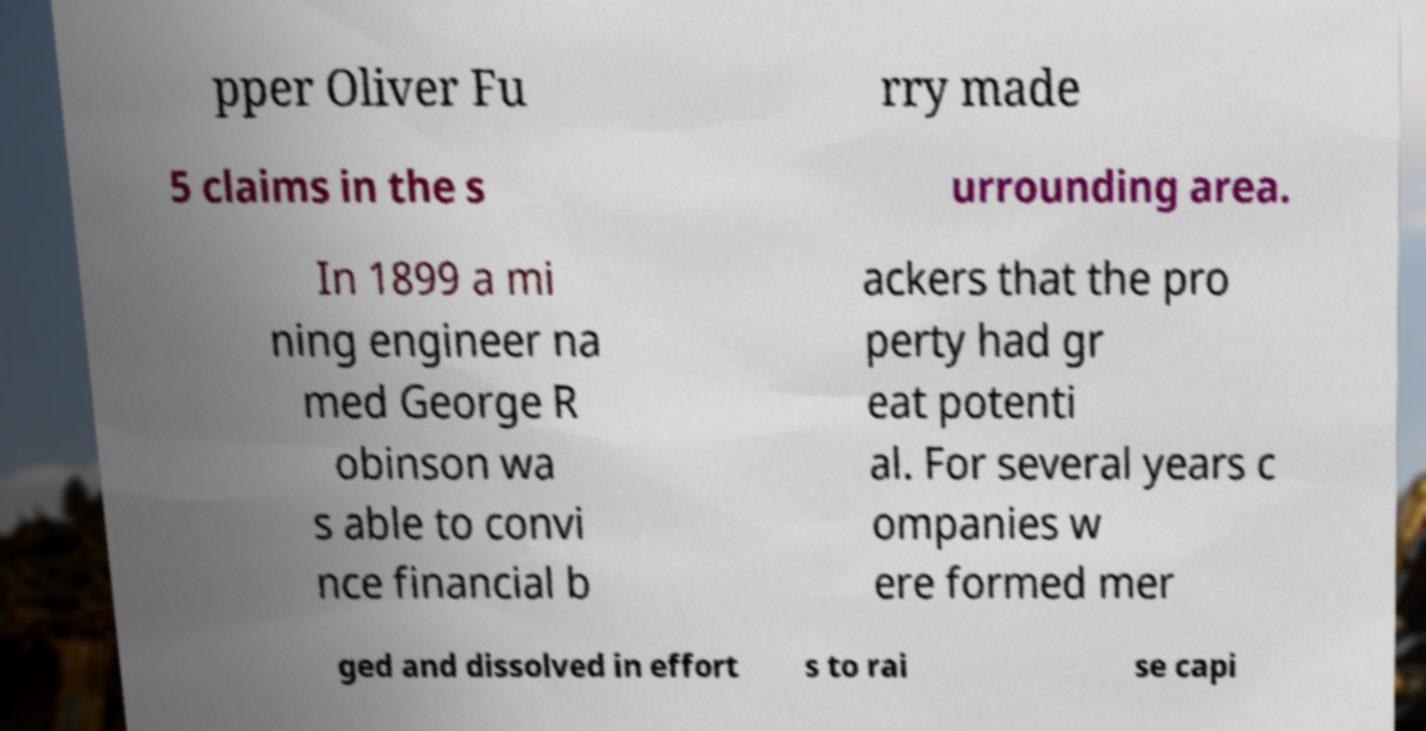Can you read and provide the text displayed in the image?This photo seems to have some interesting text. Can you extract and type it out for me? pper Oliver Fu rry made 5 claims in the s urrounding area. In 1899 a mi ning engineer na med George R obinson wa s able to convi nce financial b ackers that the pro perty had gr eat potenti al. For several years c ompanies w ere formed mer ged and dissolved in effort s to rai se capi 